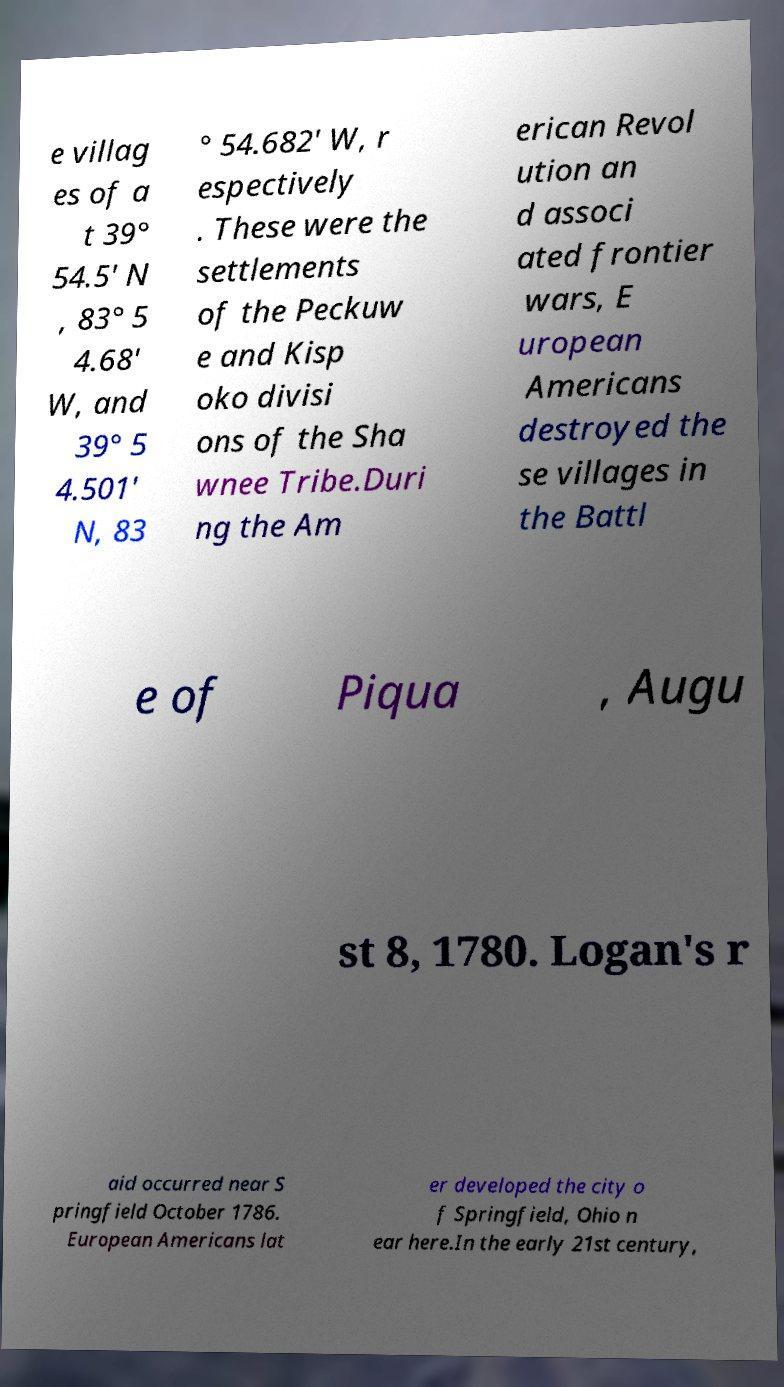Please identify and transcribe the text found in this image. e villag es of a t 39° 54.5′ N , 83° 5 4.68′ W, and 39° 5 4.501′ N, 83 ° 54.682′ W, r espectively . These were the settlements of the Peckuw e and Kisp oko divisi ons of the Sha wnee Tribe.Duri ng the Am erican Revol ution an d associ ated frontier wars, E uropean Americans destroyed the se villages in the Battl e of Piqua , Augu st 8, 1780. Logan's r aid occurred near S pringfield October 1786. European Americans lat er developed the city o f Springfield, Ohio n ear here.In the early 21st century, 